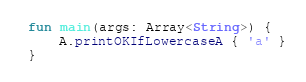Convert code to text. <code><loc_0><loc_0><loc_500><loc_500><_Kotlin_>fun main(args: Array<String>) {
    A.printOKIfLowercaseA { 'a' }
}
</code> 